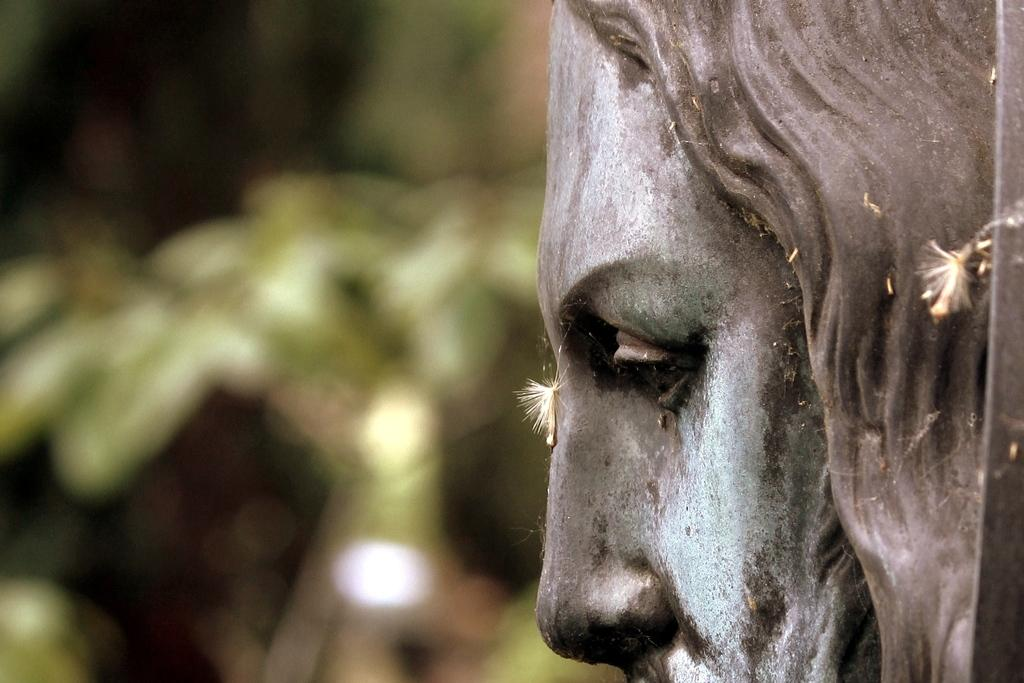What is the main subject on the right side of the image? There is a statue on the right side of the image. What type of beef is being prepared on the left side of the image? There is no beef or any cooking activity present in the image; it only features a statue on the right side. What is the statue using to create a melody in the image? There is no instrument or musical activity depicted in the image; it only features a statue. 